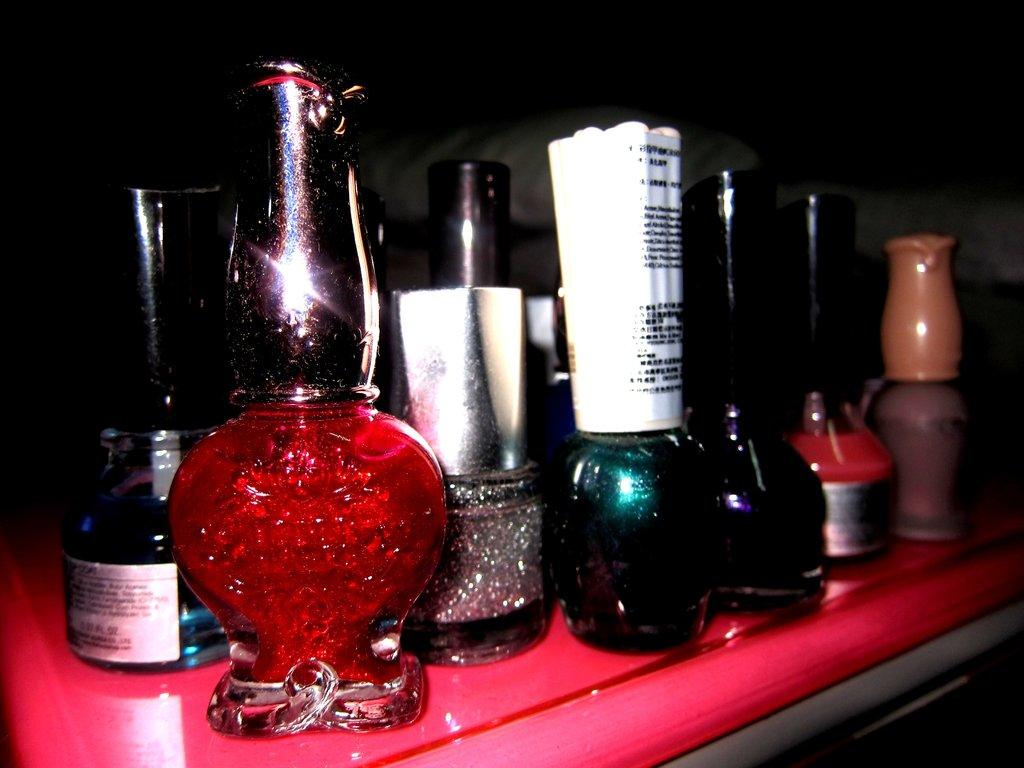What types of objects are in the foreground of the image? There are different kinds of bottles in the foreground of the image. What color is the table on which the bottles are placed? The table is pink. How would you describe the background of the image? The background of the image is dark. What level of security is provided by the army in the image? There is no army or security detail present in the image; it features bottles on a pink table with a dark background. 